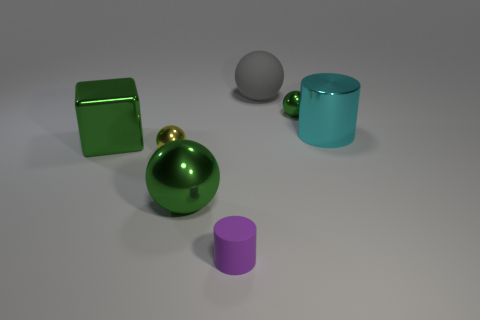Subtract all big shiny spheres. How many spheres are left? 3 Add 1 big cyan shiny cylinders. How many objects exist? 8 Subtract 1 cubes. How many cubes are left? 0 Subtract all purple cylinders. How many cylinders are left? 1 Subtract all cylinders. How many objects are left? 5 Add 5 small gray things. How many small gray things exist? 5 Subtract 0 brown cylinders. How many objects are left? 7 Subtract all yellow blocks. Subtract all gray cylinders. How many blocks are left? 1 Subtract all brown cubes. How many cyan cylinders are left? 1 Subtract all small matte cylinders. Subtract all large metallic cylinders. How many objects are left? 5 